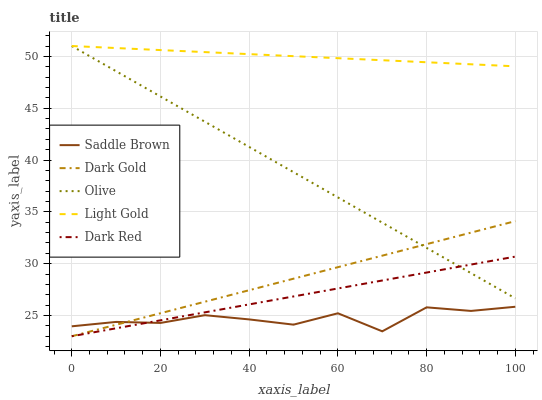Does Saddle Brown have the minimum area under the curve?
Answer yes or no. Yes. Does Light Gold have the maximum area under the curve?
Answer yes or no. Yes. Does Dark Red have the minimum area under the curve?
Answer yes or no. No. Does Dark Red have the maximum area under the curve?
Answer yes or no. No. Is Dark Red the smoothest?
Answer yes or no. Yes. Is Saddle Brown the roughest?
Answer yes or no. Yes. Is Light Gold the smoothest?
Answer yes or no. No. Is Light Gold the roughest?
Answer yes or no. No. Does Dark Red have the lowest value?
Answer yes or no. Yes. Does Light Gold have the lowest value?
Answer yes or no. No. Does Light Gold have the highest value?
Answer yes or no. Yes. Does Dark Red have the highest value?
Answer yes or no. No. Is Dark Gold less than Light Gold?
Answer yes or no. Yes. Is Olive greater than Saddle Brown?
Answer yes or no. Yes. Does Dark Red intersect Saddle Brown?
Answer yes or no. Yes. Is Dark Red less than Saddle Brown?
Answer yes or no. No. Is Dark Red greater than Saddle Brown?
Answer yes or no. No. Does Dark Gold intersect Light Gold?
Answer yes or no. No. 